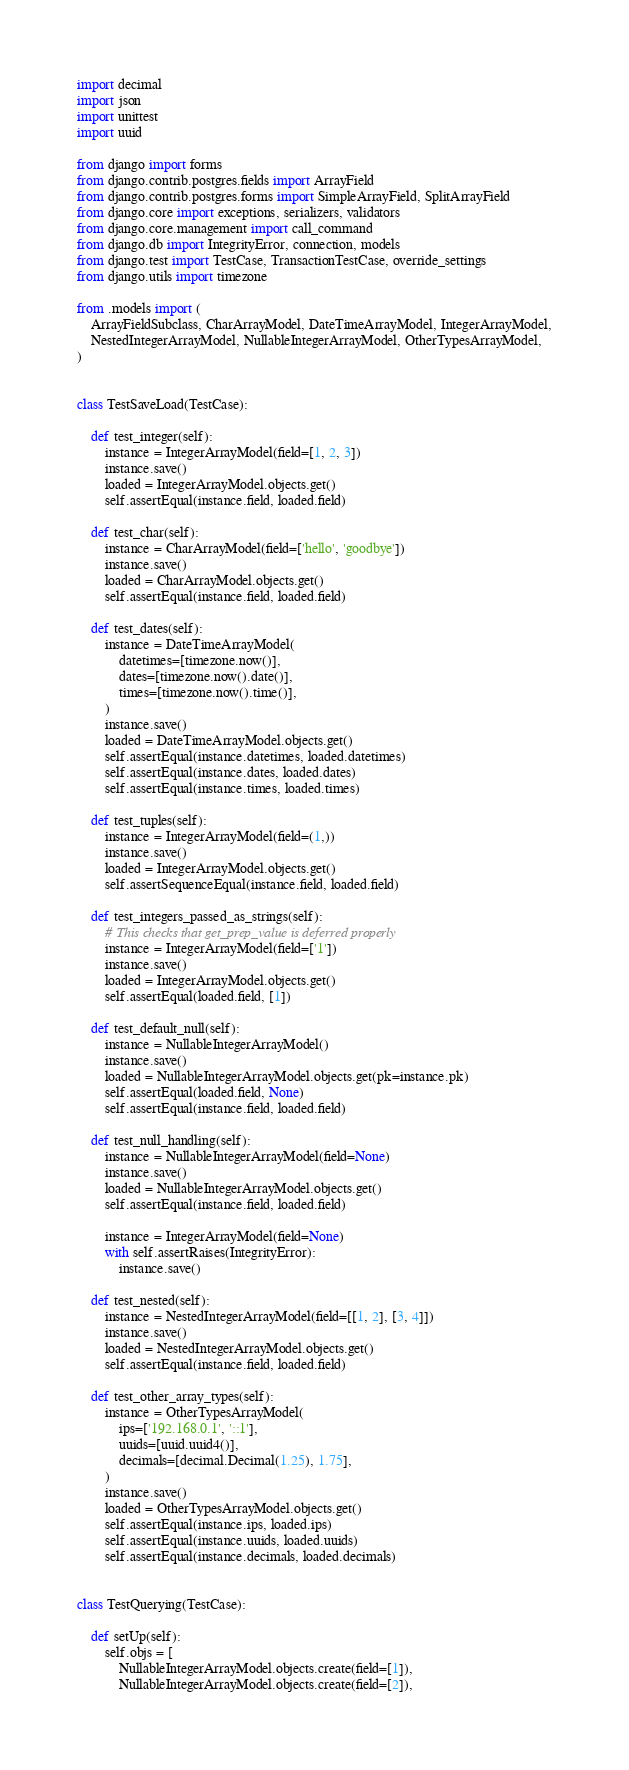Convert code to text. <code><loc_0><loc_0><loc_500><loc_500><_Python_>import decimal
import json
import unittest
import uuid

from django import forms
from django.contrib.postgres.fields import ArrayField
from django.contrib.postgres.forms import SimpleArrayField, SplitArrayField
from django.core import exceptions, serializers, validators
from django.core.management import call_command
from django.db import IntegrityError, connection, models
from django.test import TestCase, TransactionTestCase, override_settings
from django.utils import timezone

from .models import (
    ArrayFieldSubclass, CharArrayModel, DateTimeArrayModel, IntegerArrayModel,
    NestedIntegerArrayModel, NullableIntegerArrayModel, OtherTypesArrayModel,
)


class TestSaveLoad(TestCase):

    def test_integer(self):
        instance = IntegerArrayModel(field=[1, 2, 3])
        instance.save()
        loaded = IntegerArrayModel.objects.get()
        self.assertEqual(instance.field, loaded.field)

    def test_char(self):
        instance = CharArrayModel(field=['hello', 'goodbye'])
        instance.save()
        loaded = CharArrayModel.objects.get()
        self.assertEqual(instance.field, loaded.field)

    def test_dates(self):
        instance = DateTimeArrayModel(
            datetimes=[timezone.now()],
            dates=[timezone.now().date()],
            times=[timezone.now().time()],
        )
        instance.save()
        loaded = DateTimeArrayModel.objects.get()
        self.assertEqual(instance.datetimes, loaded.datetimes)
        self.assertEqual(instance.dates, loaded.dates)
        self.assertEqual(instance.times, loaded.times)

    def test_tuples(self):
        instance = IntegerArrayModel(field=(1,))
        instance.save()
        loaded = IntegerArrayModel.objects.get()
        self.assertSequenceEqual(instance.field, loaded.field)

    def test_integers_passed_as_strings(self):
        # This checks that get_prep_value is deferred properly
        instance = IntegerArrayModel(field=['1'])
        instance.save()
        loaded = IntegerArrayModel.objects.get()
        self.assertEqual(loaded.field, [1])

    def test_default_null(self):
        instance = NullableIntegerArrayModel()
        instance.save()
        loaded = NullableIntegerArrayModel.objects.get(pk=instance.pk)
        self.assertEqual(loaded.field, None)
        self.assertEqual(instance.field, loaded.field)

    def test_null_handling(self):
        instance = NullableIntegerArrayModel(field=None)
        instance.save()
        loaded = NullableIntegerArrayModel.objects.get()
        self.assertEqual(instance.field, loaded.field)

        instance = IntegerArrayModel(field=None)
        with self.assertRaises(IntegrityError):
            instance.save()

    def test_nested(self):
        instance = NestedIntegerArrayModel(field=[[1, 2], [3, 4]])
        instance.save()
        loaded = NestedIntegerArrayModel.objects.get()
        self.assertEqual(instance.field, loaded.field)

    def test_other_array_types(self):
        instance = OtherTypesArrayModel(
            ips=['192.168.0.1', '::1'],
            uuids=[uuid.uuid4()],
            decimals=[decimal.Decimal(1.25), 1.75],
        )
        instance.save()
        loaded = OtherTypesArrayModel.objects.get()
        self.assertEqual(instance.ips, loaded.ips)
        self.assertEqual(instance.uuids, loaded.uuids)
        self.assertEqual(instance.decimals, loaded.decimals)


class TestQuerying(TestCase):

    def setUp(self):
        self.objs = [
            NullableIntegerArrayModel.objects.create(field=[1]),
            NullableIntegerArrayModel.objects.create(field=[2]),</code> 